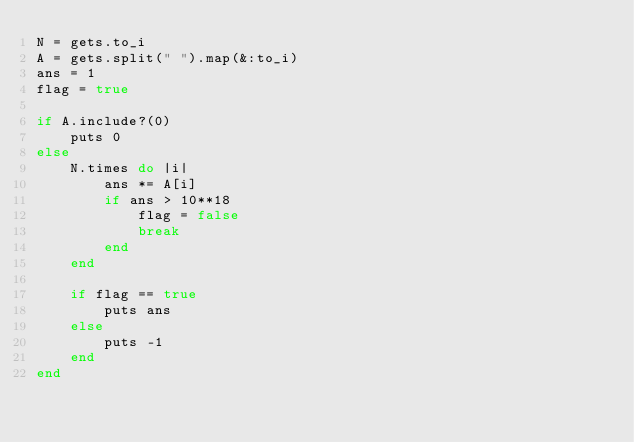Convert code to text. <code><loc_0><loc_0><loc_500><loc_500><_Ruby_>N = gets.to_i
A = gets.split(" ").map(&:to_i)
ans = 1
flag = true

if A.include?(0)
    puts 0
else
    N.times do |i|
        ans *= A[i]
        if ans > 10**18
            flag = false 
            break
        end
    end
    
    if flag == true 
        puts ans
    else
        puts -1
    end
end</code> 